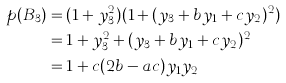<formula> <loc_0><loc_0><loc_500><loc_500>p ( B _ { 3 } ) & = ( 1 + y _ { 3 } ^ { 2 } ) ( 1 + ( y _ { 3 } + b y _ { 1 } + c y _ { 2 } ) ^ { 2 } ) \\ & = 1 + y _ { 3 } ^ { 2 } + ( y _ { 3 } + b y _ { 1 } + c y _ { 2 } ) ^ { 2 } \\ & = 1 + c ( 2 b - a c ) y _ { 1 } y _ { 2 }</formula> 